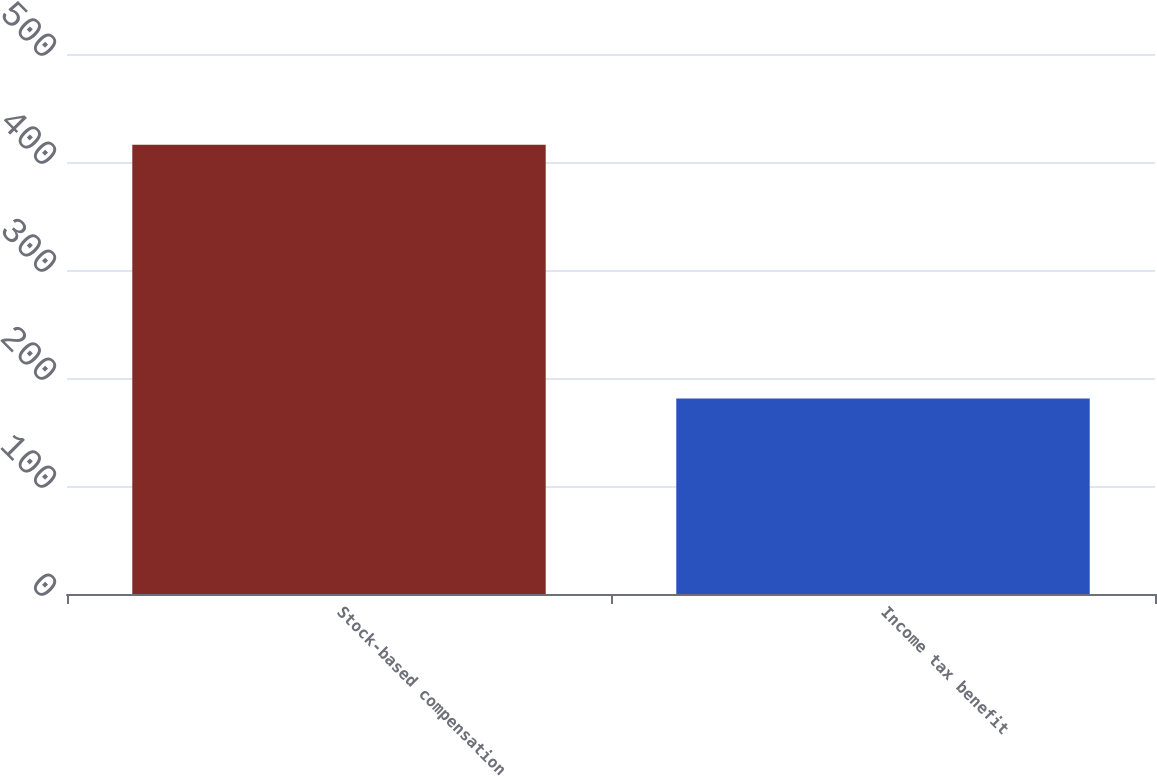Convert chart to OTSL. <chart><loc_0><loc_0><loc_500><loc_500><bar_chart><fcel>Stock-based compensation<fcel>Income tax benefit<nl><fcel>416<fcel>181<nl></chart> 